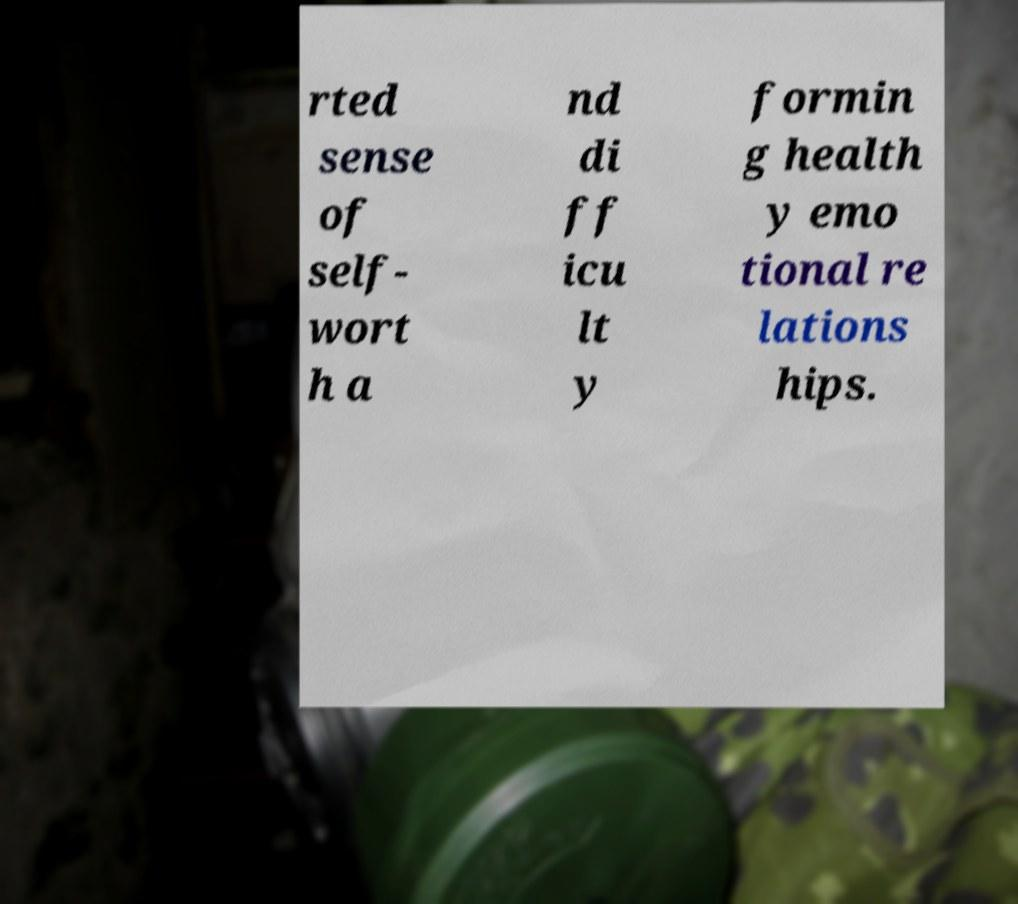Could you extract and type out the text from this image? rted sense of self- wort h a nd di ff icu lt y formin g health y emo tional re lations hips. 